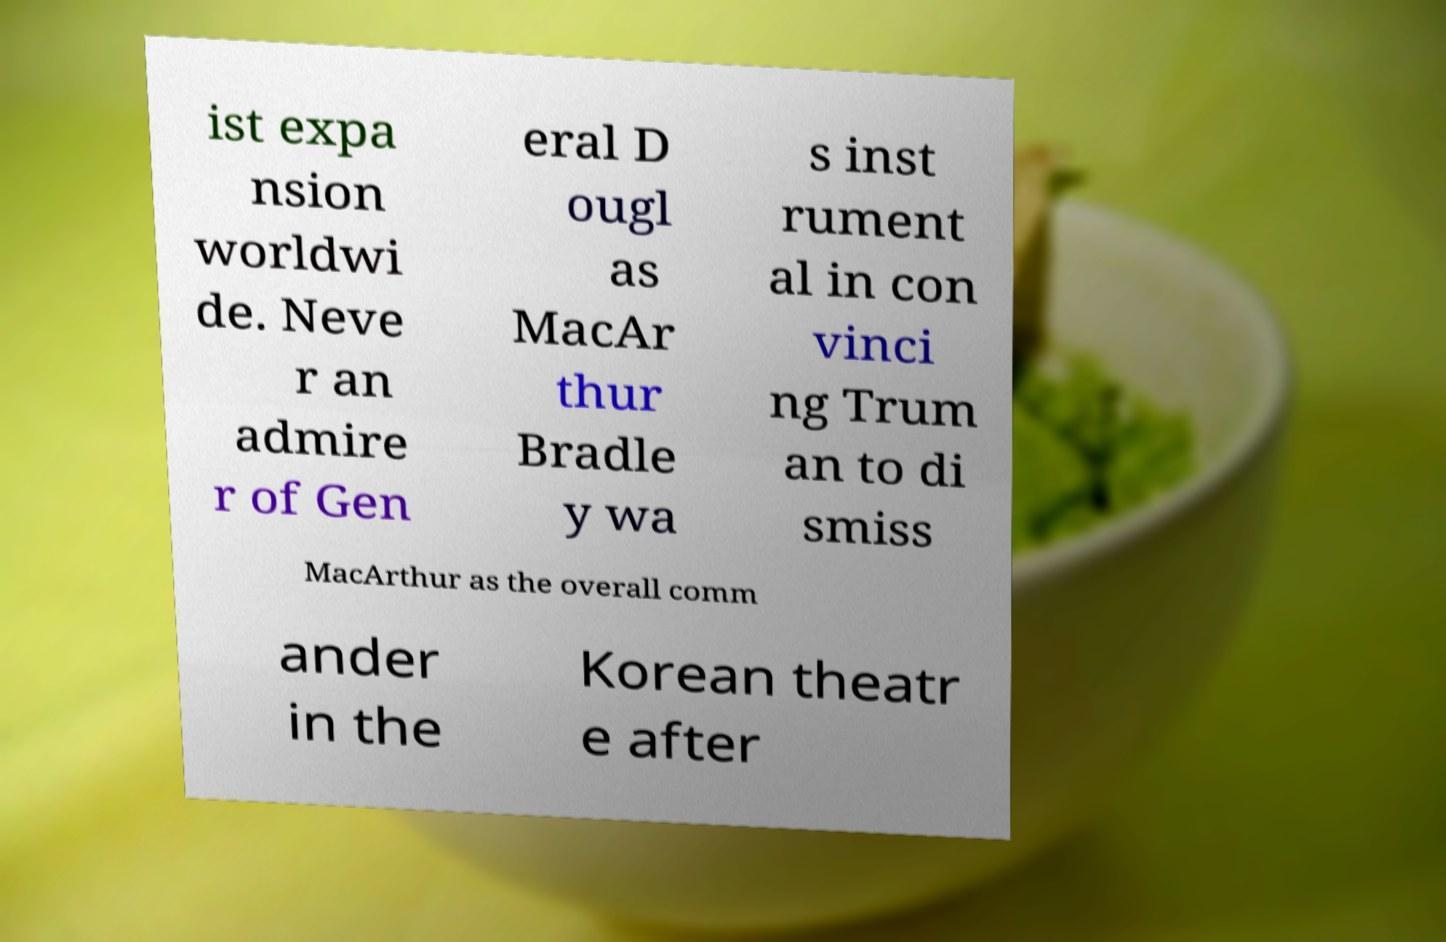Could you assist in decoding the text presented in this image and type it out clearly? ist expa nsion worldwi de. Neve r an admire r of Gen eral D ougl as MacAr thur Bradle y wa s inst rument al in con vinci ng Trum an to di smiss MacArthur as the overall comm ander in the Korean theatr e after 